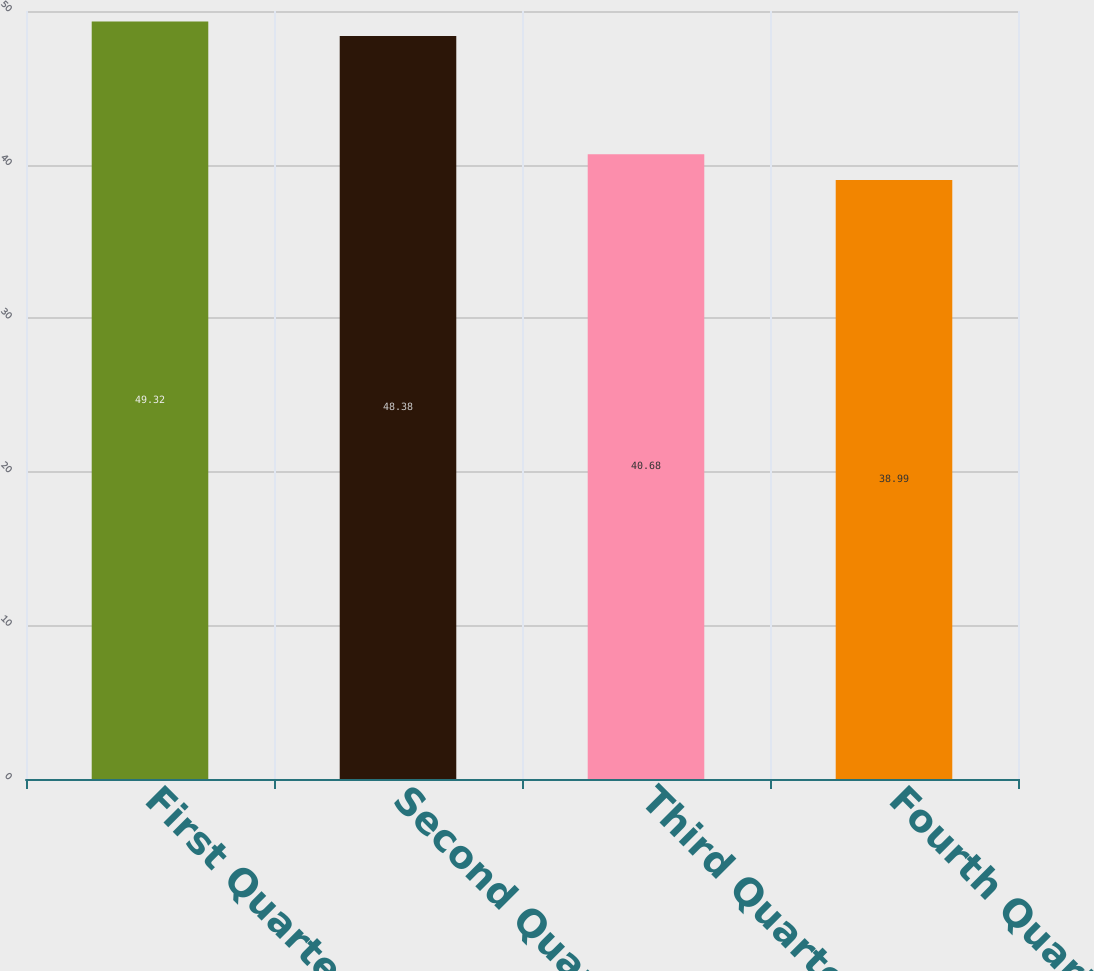Convert chart. <chart><loc_0><loc_0><loc_500><loc_500><bar_chart><fcel>First Quarter<fcel>Second Quarter<fcel>Third Quarter<fcel>Fourth Quarter<nl><fcel>49.32<fcel>48.38<fcel>40.68<fcel>38.99<nl></chart> 